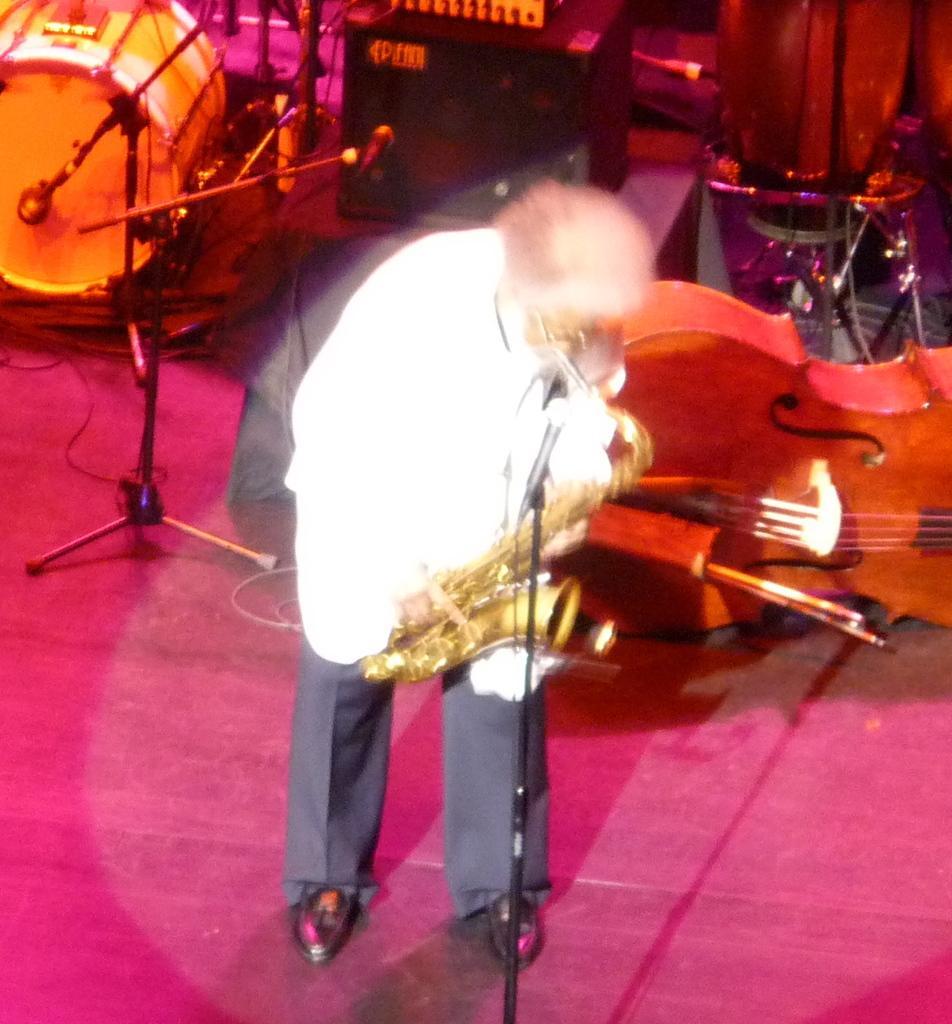How would you summarize this image in a sentence or two? There is a man standing in stage and playing sousaphone in front of microphone. Behind him there are so many musical instruments. 